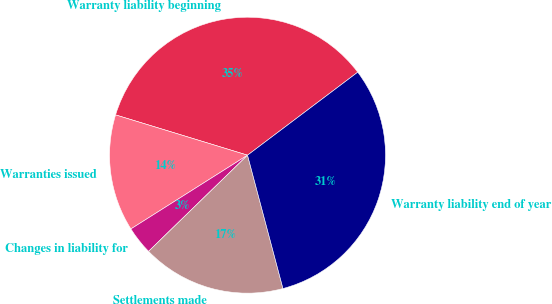Convert chart. <chart><loc_0><loc_0><loc_500><loc_500><pie_chart><fcel>Warranty liability beginning<fcel>Warranties issued<fcel>Changes in liability for<fcel>Settlements made<fcel>Warranty liability end of year<nl><fcel>35.01%<fcel>13.69%<fcel>3.3%<fcel>16.86%<fcel>31.14%<nl></chart> 